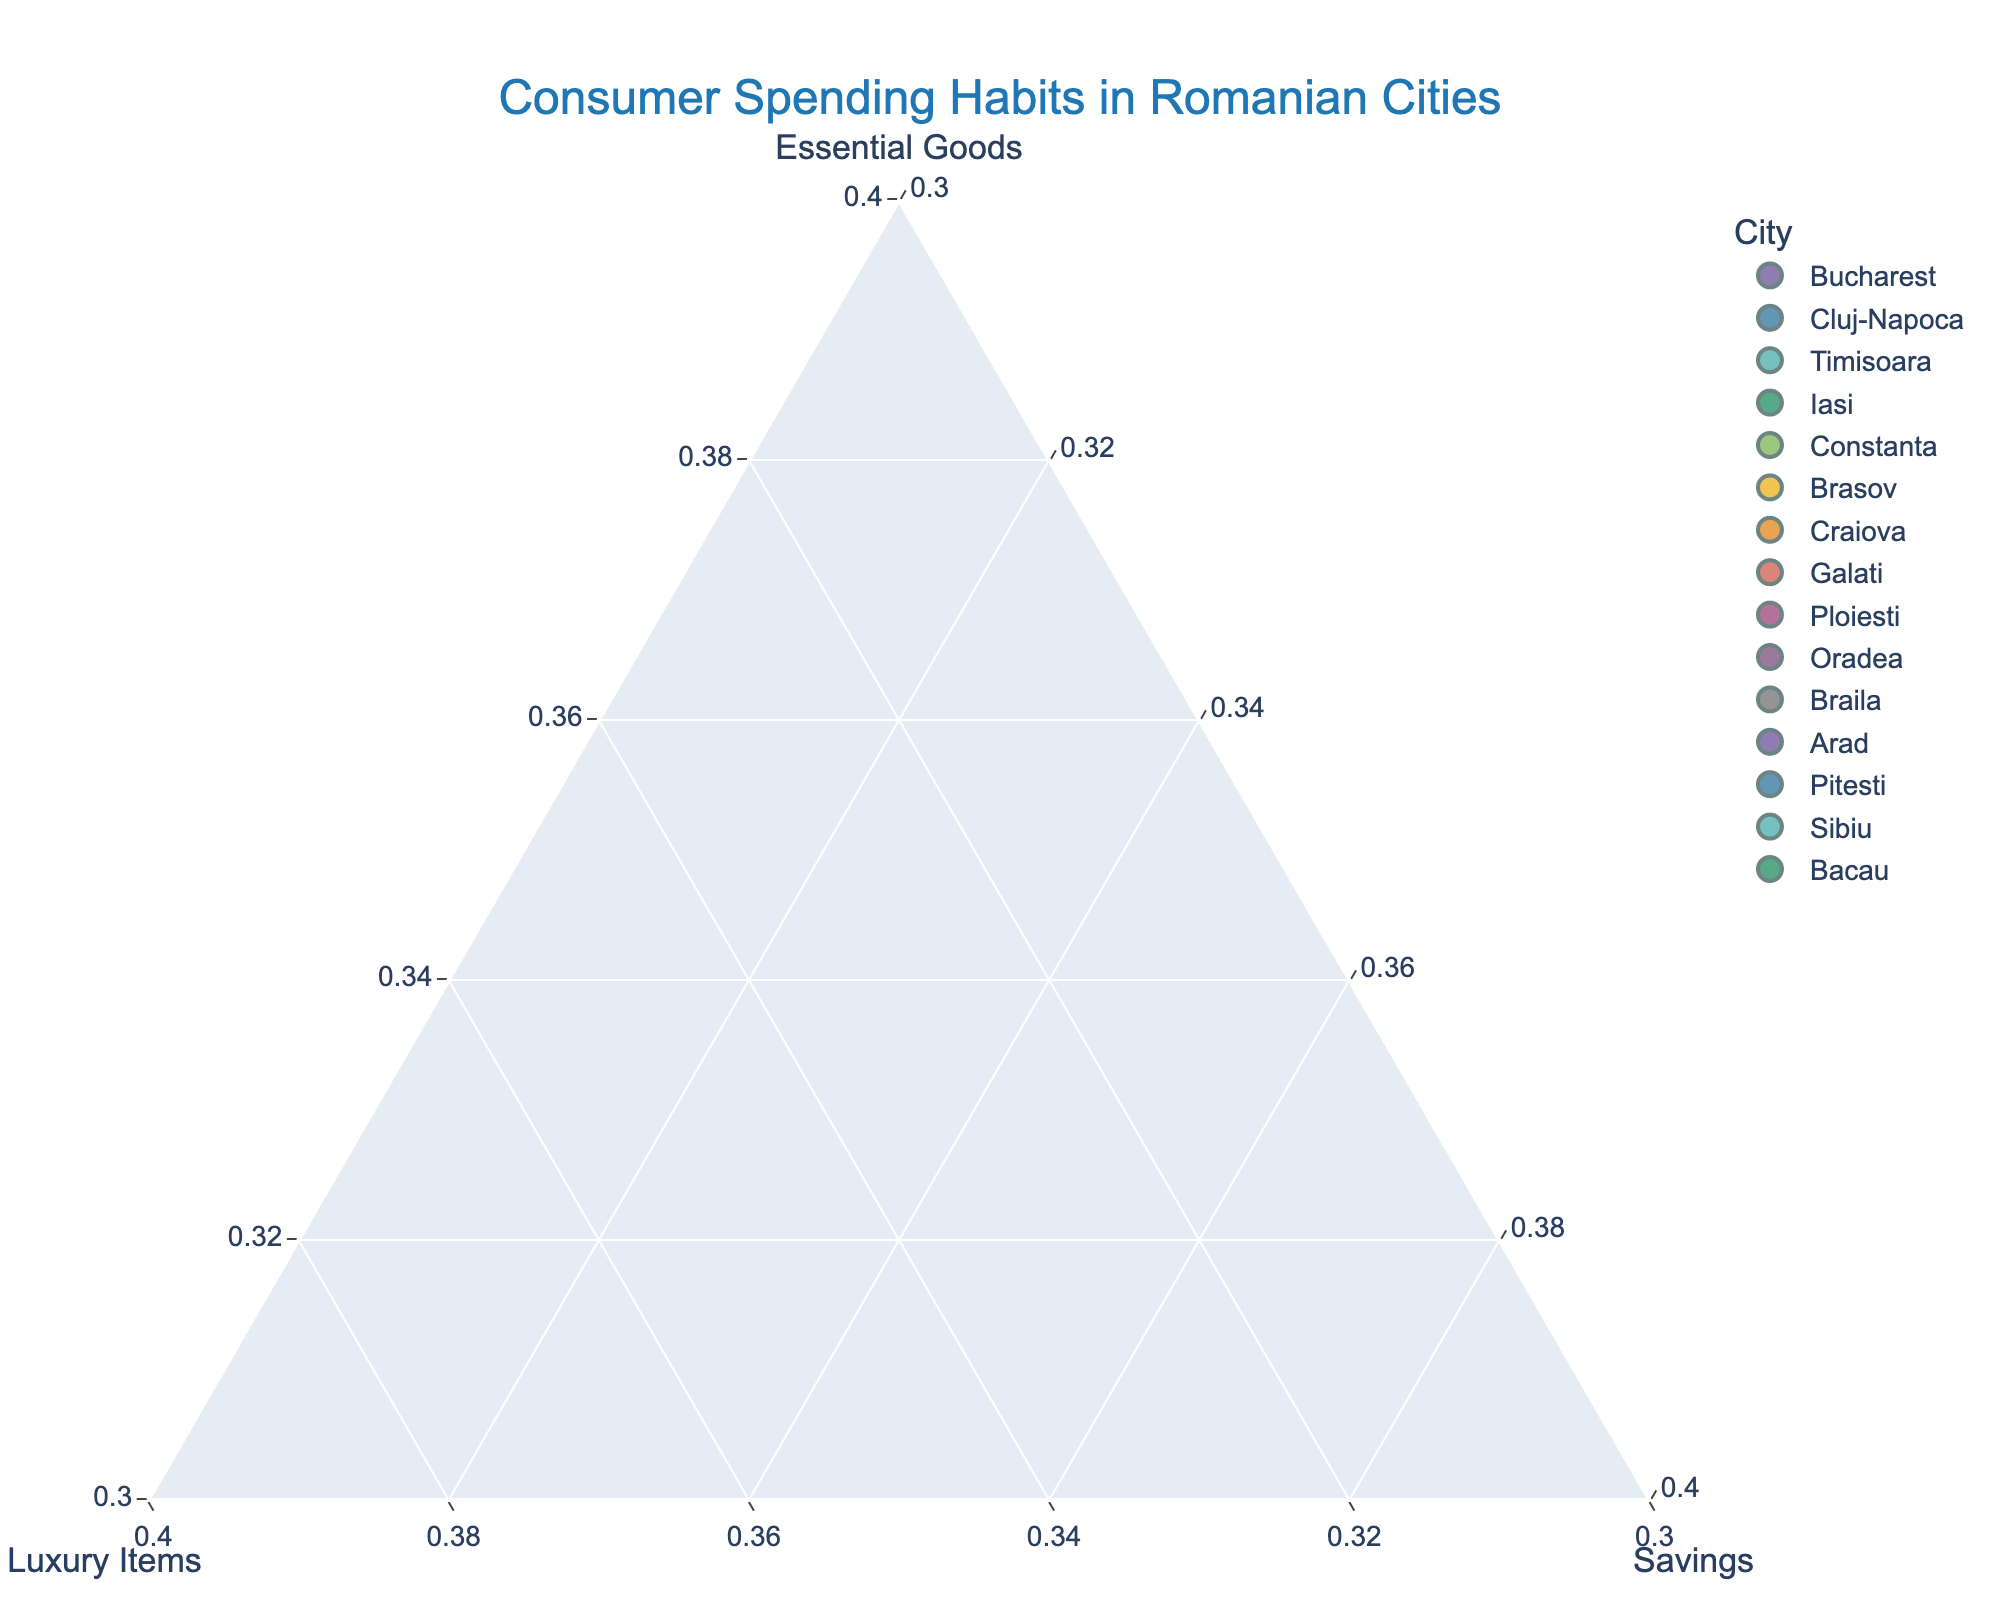How many cities are represented in the plot? By counting the data points in the figure, we can determine that each data point represents a city. The plot title indicates that it displays "Consumer Spending Habits in Romanian Cities," so each distinctive point corresponds to one city.
Answer: 15 Which city has the highest expenditure on Essential Goods? By examining the positions of the data points relative to the Essential Goods axis, we can identify that the city closest to the vertex labeled "Essential Goods" has the highest expenditure in this category. The city with 70% expenditure on Essential Goods is Braila.
Answer: Braila Which city spends the most on Luxury Items? Examining the Luxury Items axis, we look for the data point closest to the vertex named "Luxury Items." This city is Sibiu, having 35% of its expenditure on Luxury Items.
Answer: Sibiu What is the average percentage of expenditure on Savings across all cities? Sum the percentages of Savings for each city and then divide by the number of cities. The percentages are mostly 20%, with exceptional values of 15% and 10% sporadically distributed. Thus, calculating: (20+20+20+20+20+25+15+15+15+25+20+15+10+15+10)/15 = 17 (%).
Answer: 17% Which city balances its spending most evenly across Essential Goods, Luxury Items, and Savings? A city that balances its spending evenly will have its data point near the center of the triangle. Upon analyzing the plot, Bucharest, with percentages of 50% Essential Goods, 30% Luxury Items, and 20% Savings, appears closest to such an even distribution.
Answer: Bucharest How does the spending on Essential Goods in Bucharest compare to that in Pitesti? Comparing the positions of Bucharest and Pitesti along the Essential Goods axis, Bucharest spends 50% on Essential Goods, while Pitesti spends 60%. Pitesti spends 10% more on Essential Goods than Bucharest.
Answer: Pitesti spends 10% more Which city has the lowest percentage of Savings? By examining which data points are furthest from the Savings vertex, we identify that the cities with the lowest percentage of Savings are Pitesti and Bacau, both allocating only 10% to Savings.
Answer: Pitesti and Bacau What is the combined percentage of Luxury Items and Savings for Cluj-Napoca? Sum the percentages of Luxury Items and Savings for Cluj-Napoca: 25% + 20% = 45%.
Answer: 45% Can you identify a city that has equal spending on Luxury Items and Savings? By investigating the data points that lie on a line drawn parallel to the edge connecting the Luxury Items and Savings vertices, we recognize Cluj-Napoca and Galati with equal percentages of 20% on both Luxury Items and Savings.
Answer: Cluj-Napoca and Galati How does consumer spending in urban Romanian cities allocate between these three categories generally? Observing the entire spread of data points in the ternary plot, we see that urban Romanian cities typically allocate a higher portion of their spending to Essential Goods compared to Luxury Items and Savings. The clustering of data points closer to the Essential Goods vertex consistently affirms this pattern.
Answer: Higher on Essential Goods 